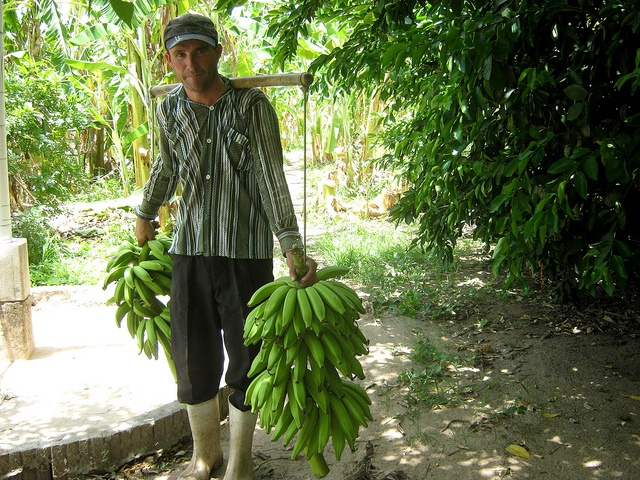Describe the objects in this image and their specific colors. I can see people in darkgray, black, gray, and darkgreen tones, banana in darkgray, darkgreen, and green tones, and banana in darkgray, darkgreen, and olive tones in this image. 